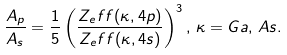<formula> <loc_0><loc_0><loc_500><loc_500>\frac { A _ { p } } { A _ { s } } = \frac { 1 } { 5 } \left ( \frac { Z _ { e } f f ( \kappa , 4 p ) } { Z _ { e } f f ( \kappa , 4 s ) } \right ) ^ { 3 } , \, \kappa = G a , \, A s .</formula> 